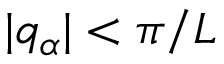<formula> <loc_0><loc_0><loc_500><loc_500>| q _ { \alpha } | < \pi / L</formula> 